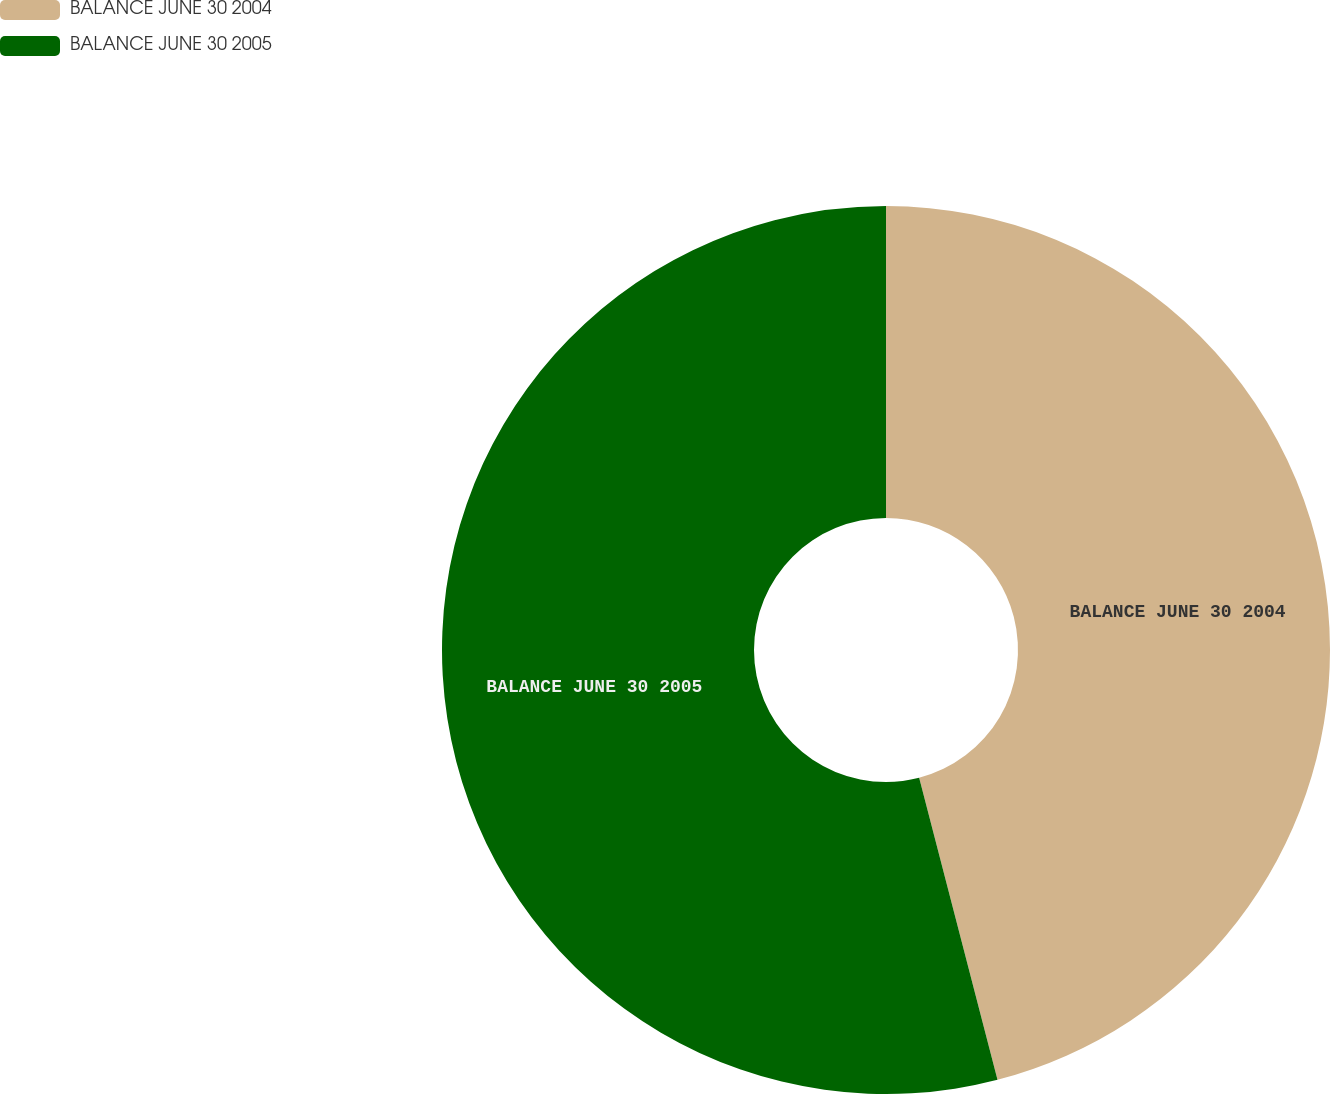<chart> <loc_0><loc_0><loc_500><loc_500><pie_chart><fcel>BALANCE JUNE 30 2004<fcel>BALANCE JUNE 30 2005<nl><fcel>45.96%<fcel>54.04%<nl></chart> 